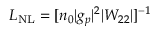Convert formula to latex. <formula><loc_0><loc_0><loc_500><loc_500>L _ { N L } = [ n _ { 0 } | g _ { p } | ^ { 2 } | W _ { 2 2 } | ] ^ { - 1 }</formula> 